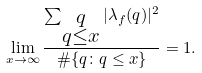<formula> <loc_0><loc_0><loc_500><loc_500>\lim _ { x \to \infty } \frac { \sum _ { \substack { q \\ q \leq x } } | \lambda _ { f } ( q ) | ^ { 2 } } { \# \{ q \colon q \leq x \} } = 1 .</formula> 